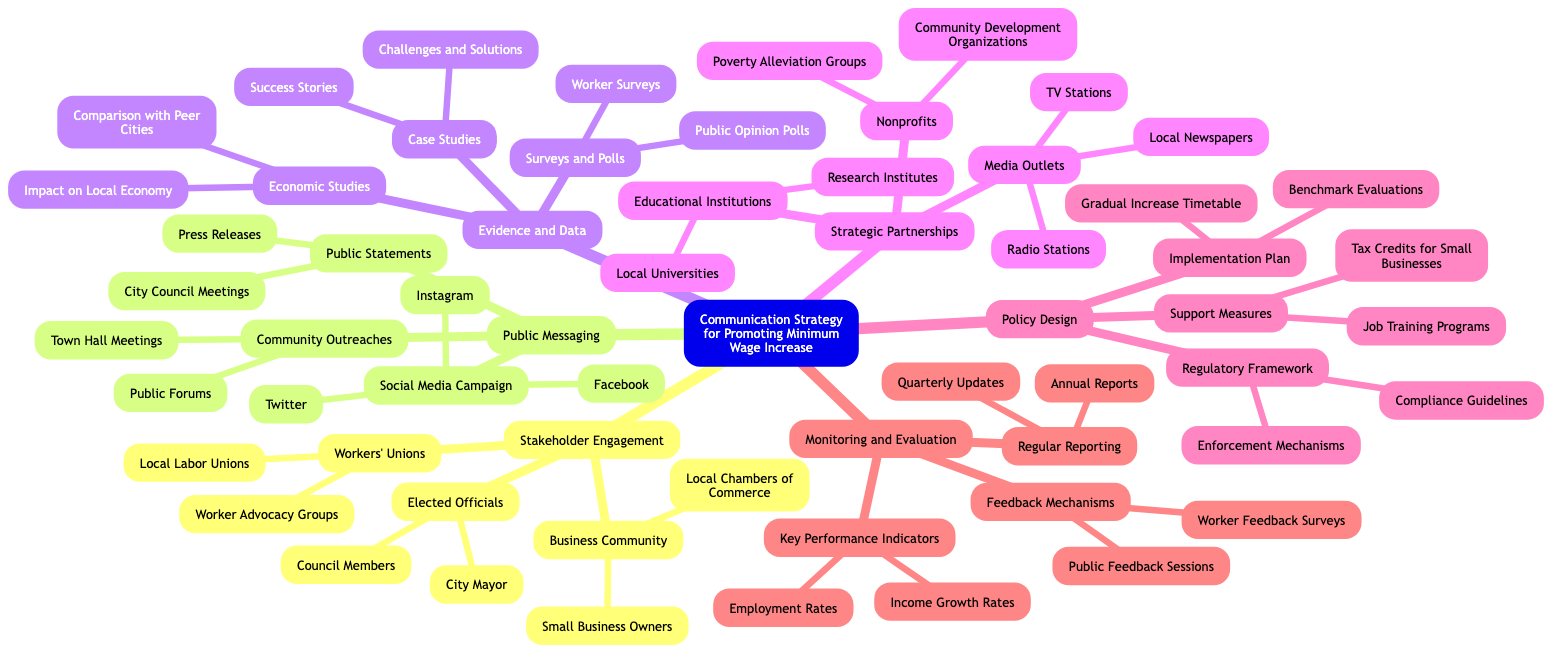What are the subcategories under Stakeholder Engagement? The node "Stakeholder Engagement" has three subcategories: "Elected Officials," "Business Community," and "Workers' Unions." These can be found directly connected under the main node.
Answer: Elected Officials, Business Community, Workers' Unions How many platforms are listed under Social Media Campaign? The node "Social Media Campaign" has three platforms listed directly beneath it: "Facebook," "Twitter," and "Instagram." I can count these platforms to get the total.
Answer: 3 What is the first item listed under Evidence and Data? Under the node "Evidence and Data," the first listed category is "Economic Studies," which is the first direct child node.
Answer: Economic Studies Which group is affiliated with the Media Outlets category? The "Media Outlets" node includes "Local Newspapers," "TV Stations," and "Radio Stations" as its affiliated groups, which are connected directly beneath it.
Answer: Local Newspapers, TV Stations, Radio Stations What are the support measures included in Policy Design? The node "Support Measures" under "Policy Design" includes two items: "Tax Credits for Small Businesses" and "Job Training Programs," which are sub-items directly beneath it.
Answer: Tax Credits for Small Businesses, Job Training Programs What do the Key Performance Indicators relate to in Monitoring and Evaluation? The "Key Performance Indicators" listed in "Monitoring and Evaluation" specifically relate to "Income Growth Rates" and "Employment Rates," both of which are child nodes under this category.
Answer: Income Growth Rates, Employment Rates Which outreach method includes Town Hall Meetings? The "Community Outreaches" node explicitly lists "Town Hall Meetings," which is one of its two sub-items, helping to identify outreach methods directly.
Answer: Town Hall Meetings How many items are listed under the Public Messaging category? The "Public Messaging" category has three distinct subcategories: "Social Media Campaign," "Public Statements," and "Community Outreaches," which I can count to determine the total items.
Answer: 3 